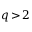<formula> <loc_0><loc_0><loc_500><loc_500>q \, > \, 2</formula> 